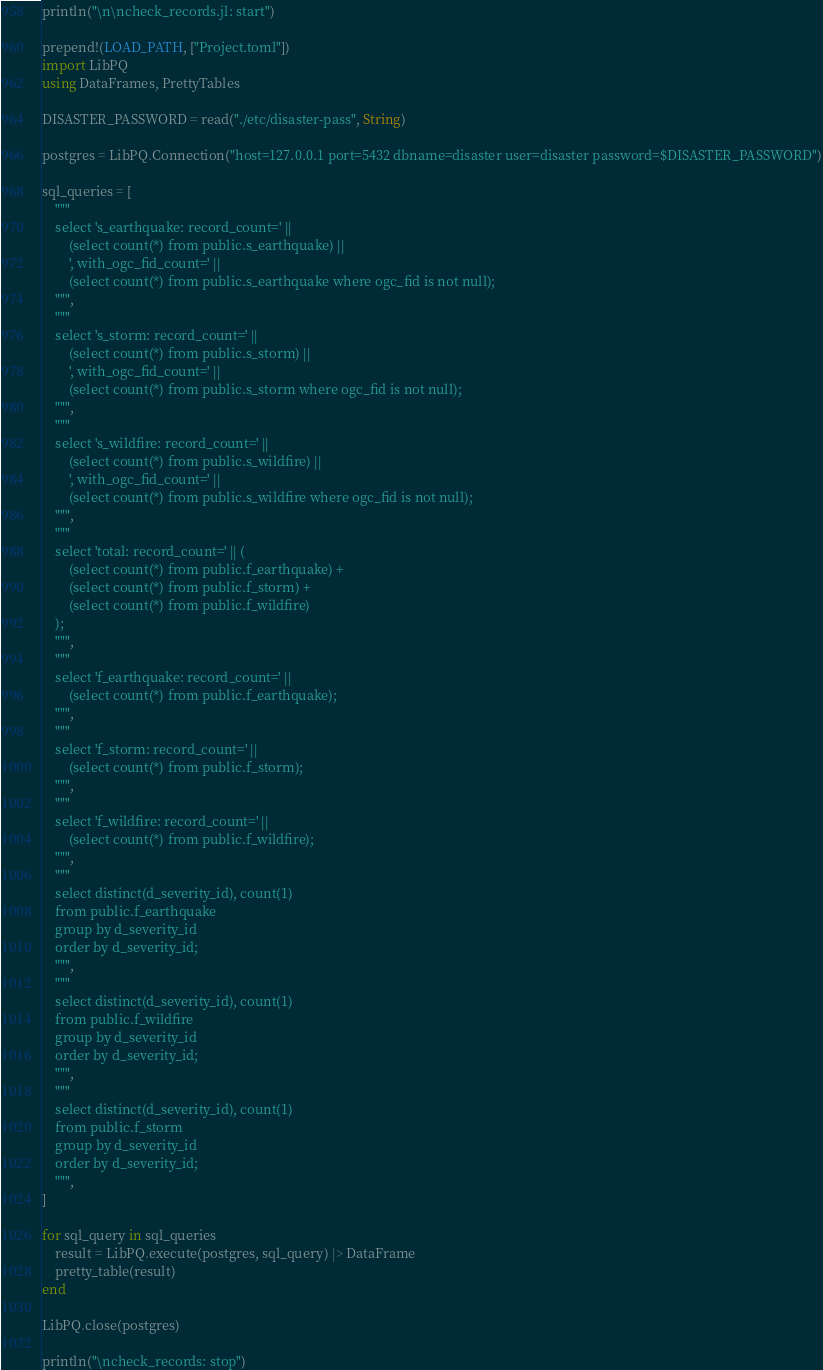Convert code to text. <code><loc_0><loc_0><loc_500><loc_500><_Julia_>println("\n\ncheck_records.jl: start")

prepend!(LOAD_PATH, ["Project.toml"])
import LibPQ
using DataFrames, PrettyTables

DISASTER_PASSWORD = read("./etc/disaster-pass", String)

postgres = LibPQ.Connection("host=127.0.0.1 port=5432 dbname=disaster user=disaster password=$DISASTER_PASSWORD")

sql_queries = [
    """
    select 's_earthquake: record_count=' ||
        (select count(*) from public.s_earthquake) ||
        ', with_ogc_fid_count=' ||
        (select count(*) from public.s_earthquake where ogc_fid is not null);
    """,
    """
    select 's_storm: record_count=' ||
        (select count(*) from public.s_storm) ||
        ', with_ogc_fid_count=' ||
        (select count(*) from public.s_storm where ogc_fid is not null);
    """,
    """
    select 's_wildfire: record_count=' ||
        (select count(*) from public.s_wildfire) ||
        ', with_ogc_fid_count=' ||
        (select count(*) from public.s_wildfire where ogc_fid is not null);
    """,
    """
    select 'total: record_count=' || (
        (select count(*) from public.f_earthquake) +
        (select count(*) from public.f_storm) +
        (select count(*) from public.f_wildfire)
    );
    """,
    """
    select 'f_earthquake: record_count=' ||
        (select count(*) from public.f_earthquake);
    """,
    """
    select 'f_storm: record_count=' ||
        (select count(*) from public.f_storm);
    """,
    """
    select 'f_wildfire: record_count=' ||
        (select count(*) from public.f_wildfire);
    """,
    """
    select distinct(d_severity_id), count(1)
    from public.f_earthquake
    group by d_severity_id
    order by d_severity_id;
    """,
    """
    select distinct(d_severity_id), count(1)
    from public.f_wildfire
    group by d_severity_id
    order by d_severity_id;
    """,
    """
    select distinct(d_severity_id), count(1)
    from public.f_storm
    group by d_severity_id
    order by d_severity_id;
    """,
]

for sql_query in sql_queries
    result = LibPQ.execute(postgres, sql_query) |> DataFrame
    pretty_table(result)
end

LibPQ.close(postgres)

println("\ncheck_records: stop")
</code> 